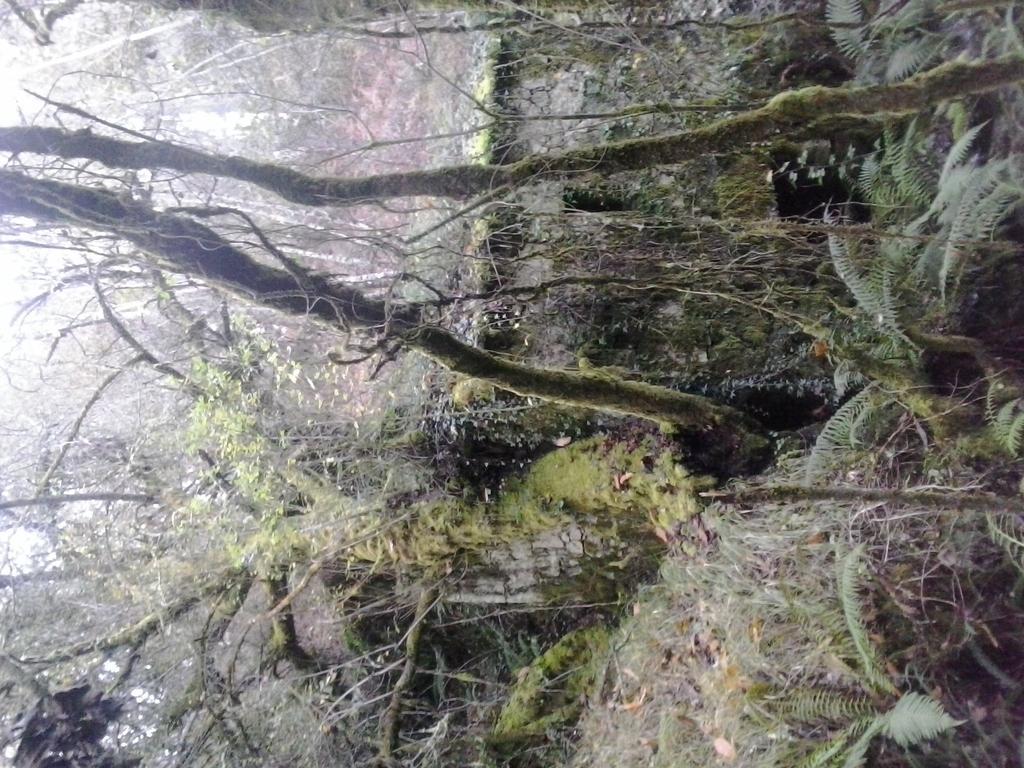In one or two sentences, can you explain what this image depicts? This picture shows few trees. 